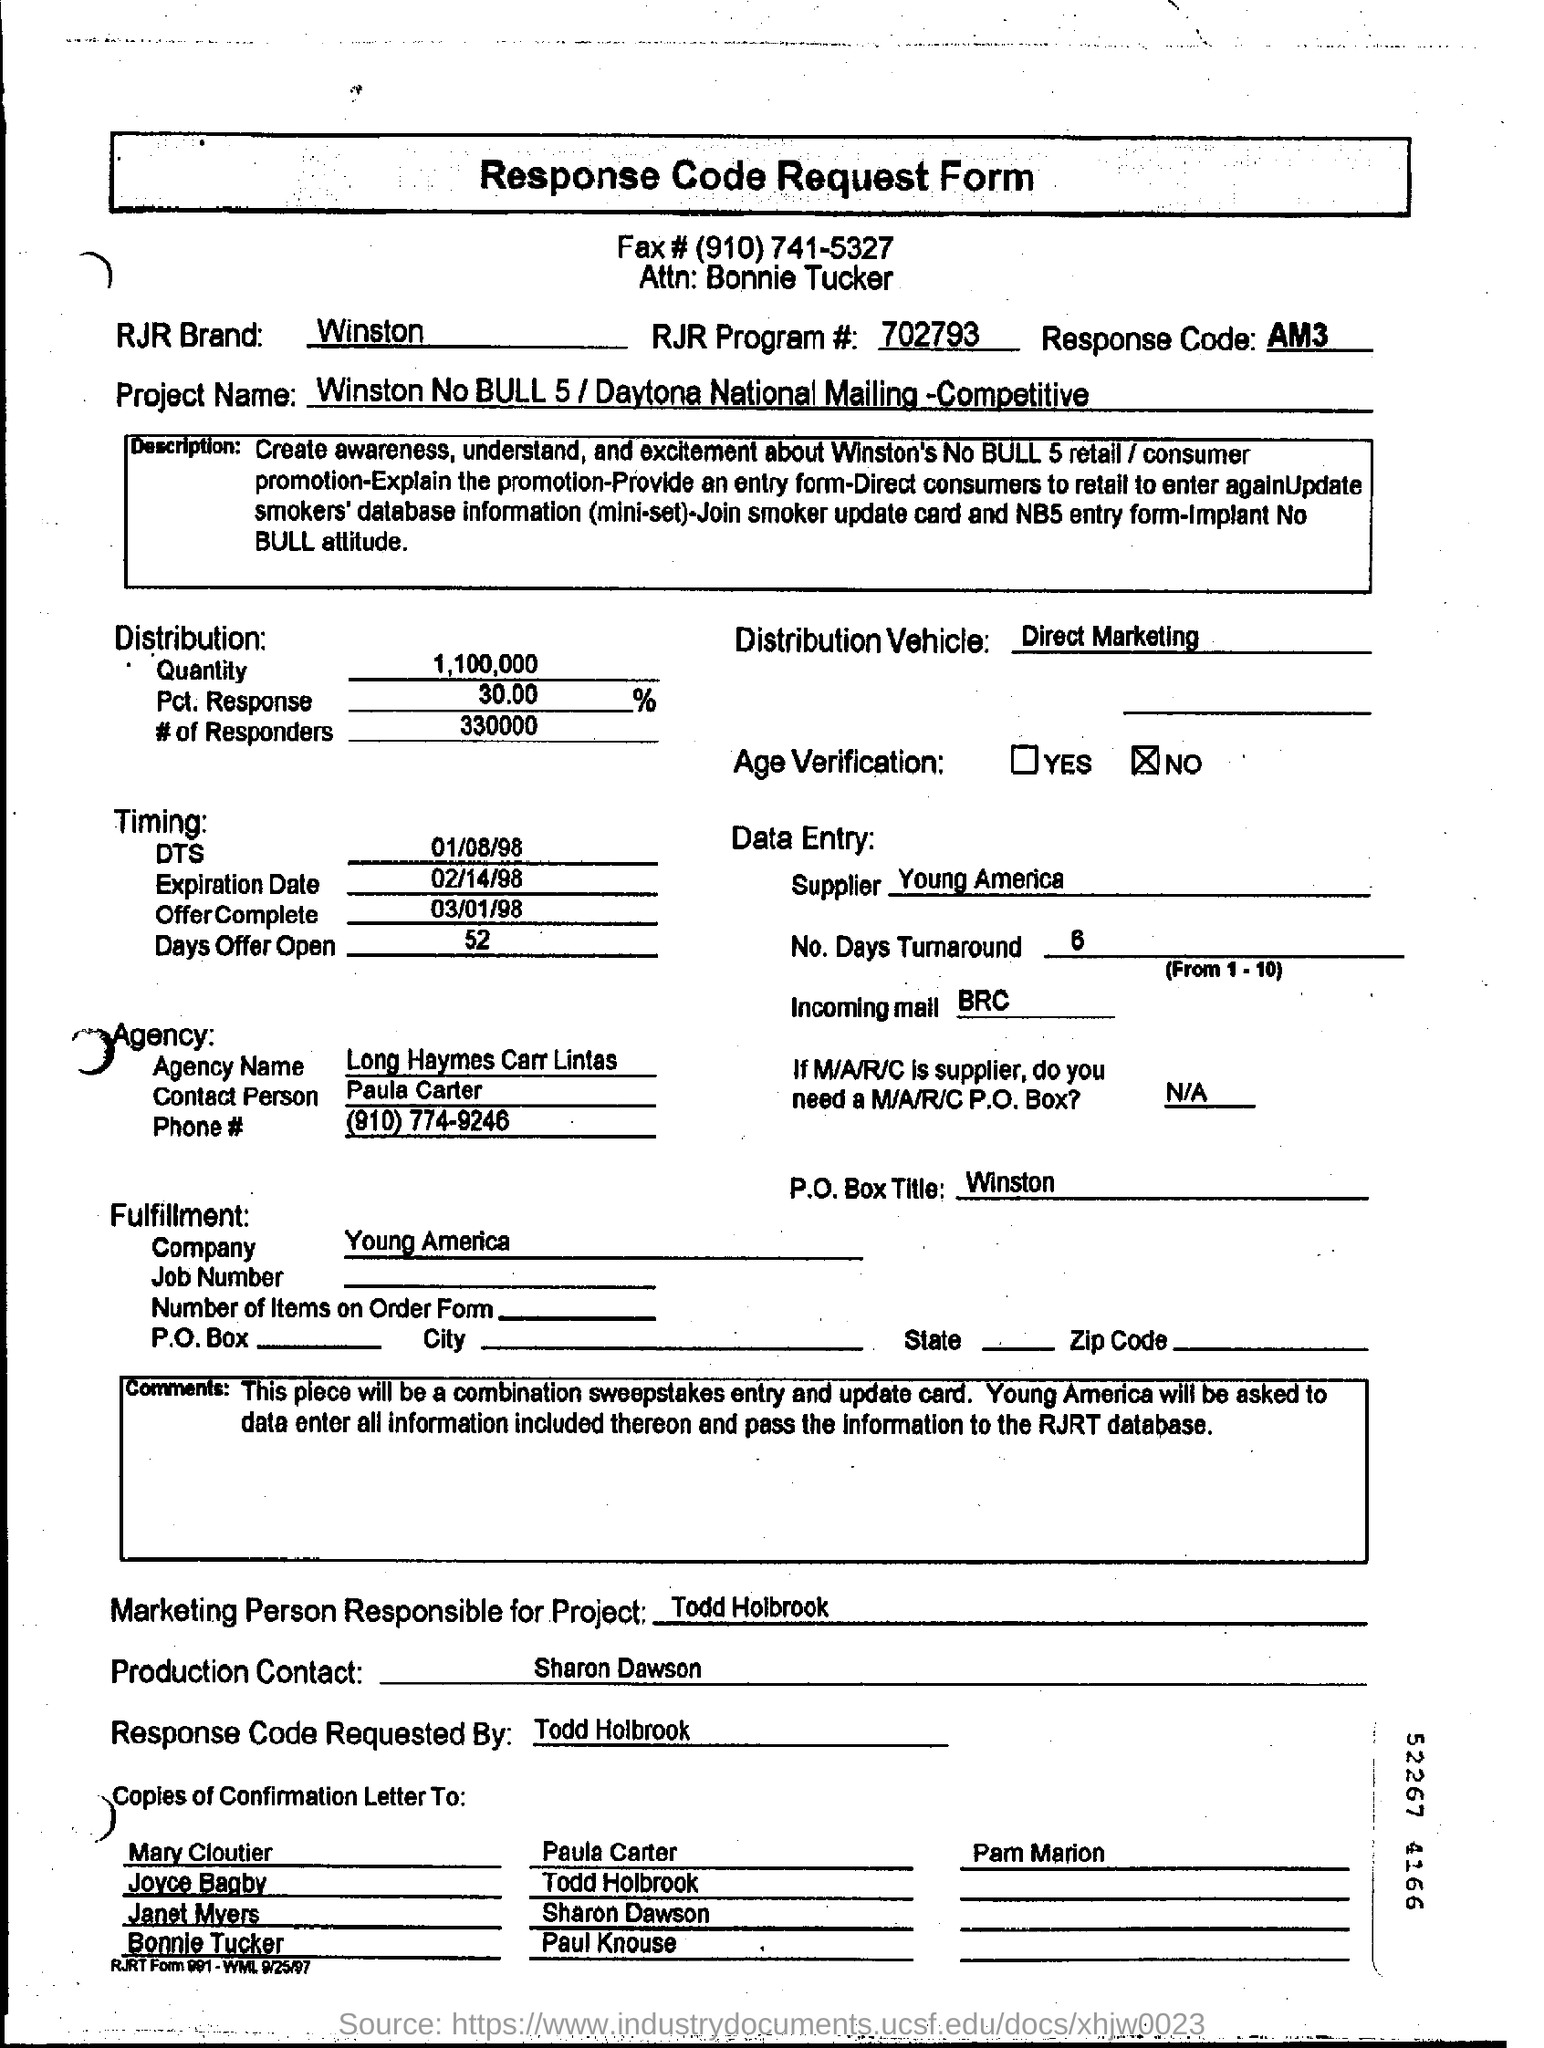What is the name of the person for the attention?
Ensure brevity in your answer.  Bonnie Tucker. What is the name of the RJR brand?
Keep it short and to the point. Winston. How much quantity for distribution?
Your answer should be very brief. 1,100,000. How many days offer open?
Provide a succinct answer. 52. Which is company supplier for the data entry ?
Make the answer very short. Young America. Who is contact person for the agency?
Make the answer very short. Paula Carter. Who is the marketing person responsible for the project?
Provide a short and direct response. Todd Holbrook. 